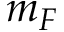<formula> <loc_0><loc_0><loc_500><loc_500>m _ { F }</formula> 